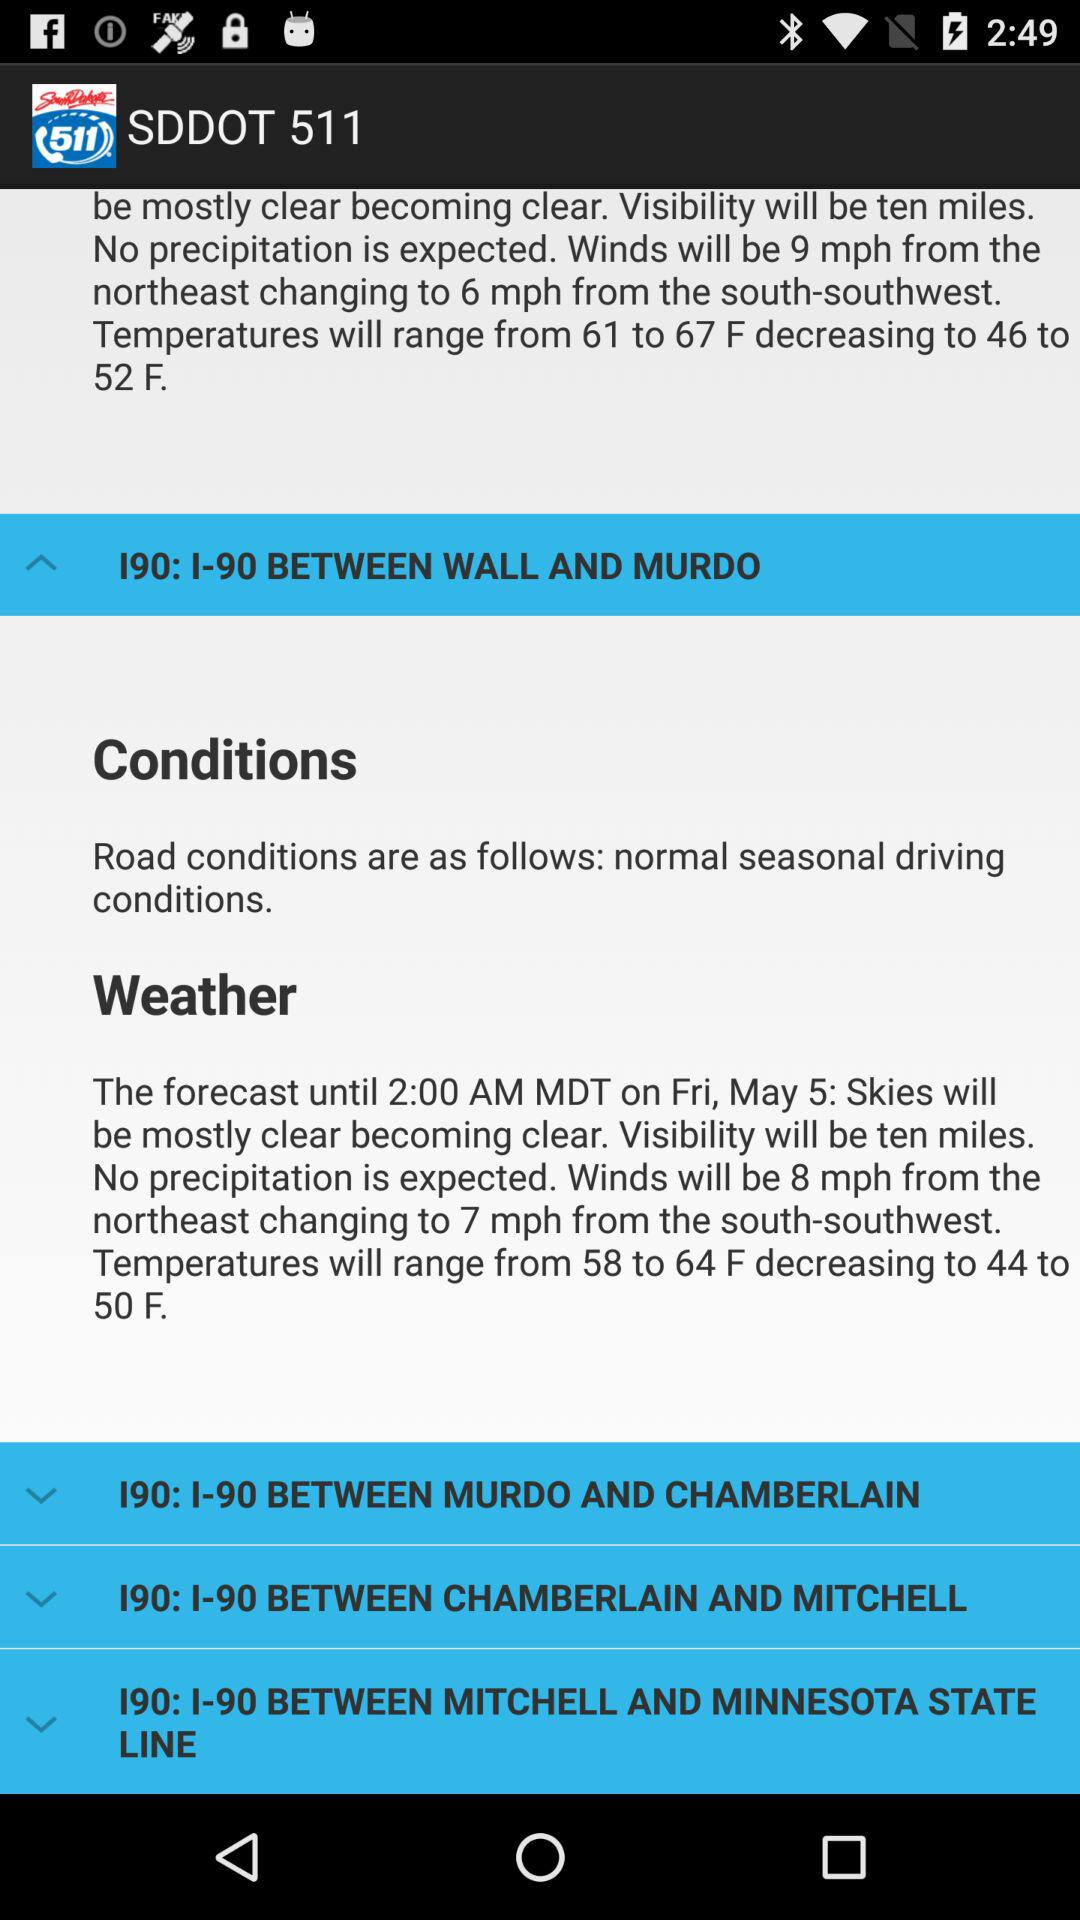What is the application name? The application name is "SDDOT 511". 